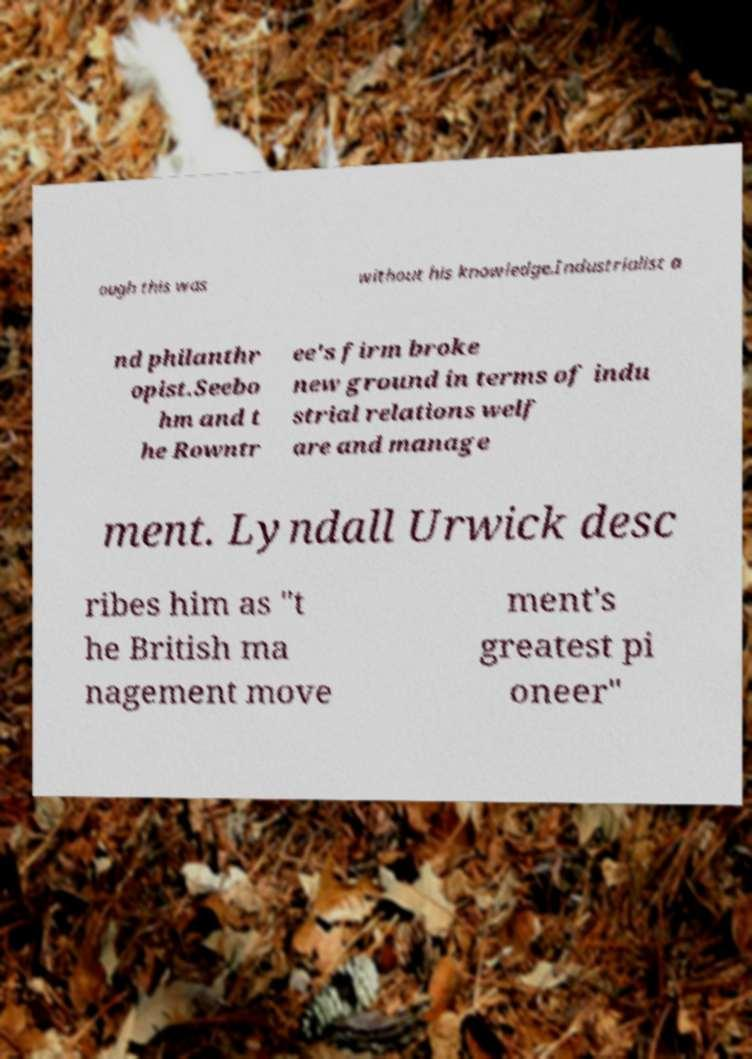What messages or text are displayed in this image? I need them in a readable, typed format. ough this was without his knowledge.Industrialist a nd philanthr opist.Seebo hm and t he Rowntr ee's firm broke new ground in terms of indu strial relations welf are and manage ment. Lyndall Urwick desc ribes him as "t he British ma nagement move ment's greatest pi oneer" 